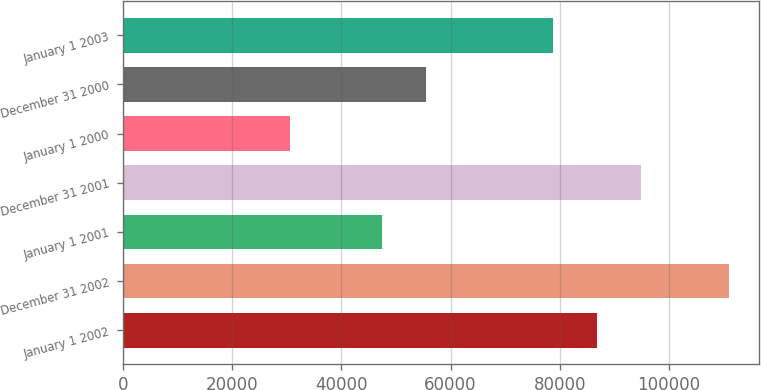Convert chart. <chart><loc_0><loc_0><loc_500><loc_500><bar_chart><fcel>January 1 2002<fcel>December 31 2002<fcel>January 1 2001<fcel>December 31 2001<fcel>January 1 2000<fcel>December 31 2000<fcel>January 1 2003<nl><fcel>86779.5<fcel>111019<fcel>47446<fcel>94813<fcel>30684<fcel>55479.5<fcel>78746<nl></chart> 